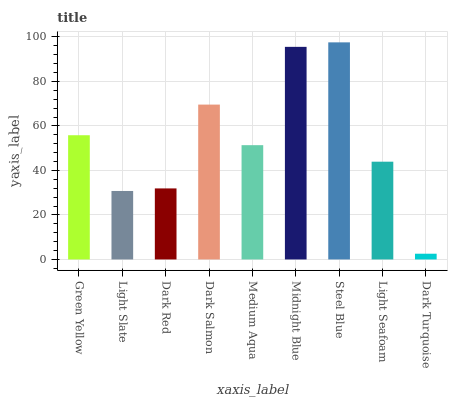Is Dark Turquoise the minimum?
Answer yes or no. Yes. Is Steel Blue the maximum?
Answer yes or no. Yes. Is Light Slate the minimum?
Answer yes or no. No. Is Light Slate the maximum?
Answer yes or no. No. Is Green Yellow greater than Light Slate?
Answer yes or no. Yes. Is Light Slate less than Green Yellow?
Answer yes or no. Yes. Is Light Slate greater than Green Yellow?
Answer yes or no. No. Is Green Yellow less than Light Slate?
Answer yes or no. No. Is Medium Aqua the high median?
Answer yes or no. Yes. Is Medium Aqua the low median?
Answer yes or no. Yes. Is Light Slate the high median?
Answer yes or no. No. Is Dark Salmon the low median?
Answer yes or no. No. 